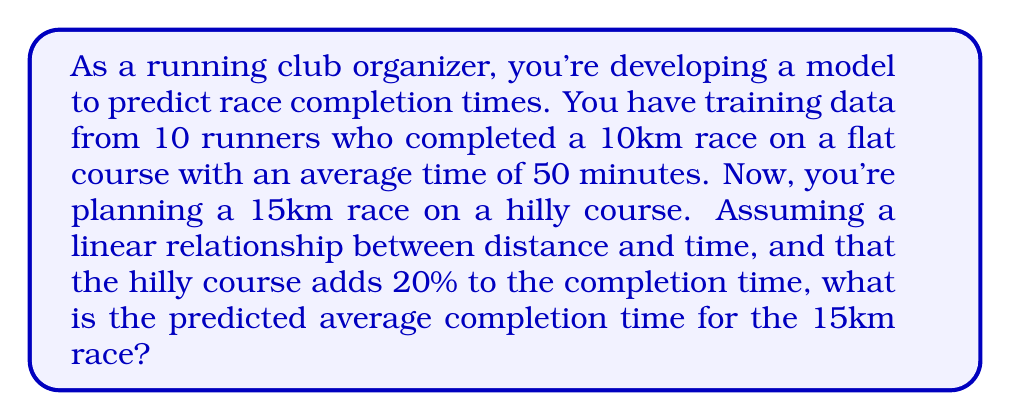Show me your answer to this math problem. Let's approach this step-by-step:

1) First, we need to establish the baseline pace for the flat 10km race:
   $$\text{Pace} = \frac{\text{Time}}{\text{Distance}} = \frac{50 \text{ minutes}}{10 \text{ km}} = 5 \text{ min/km}$$

2) Now, let's predict the time for a 15km flat course:
   $$\text{Predicted Time (flat)} = 15 \text{ km} \times 5 \text{ min/km} = 75 \text{ minutes}$$

3) The question states that the hilly course adds 20% to the completion time. To calculate this:
   $$\text{Additional Time} = 75 \text{ minutes} \times 0.20 = 15 \text{ minutes}$$

4) Therefore, the total predicted time for the 15km hilly course is:
   $$\text{Total Predicted Time} = 75 \text{ minutes} + 15 \text{ minutes} = 90 \text{ minutes}$$

This inverse problem involves using known data (10km race times) to predict unknown data (15km race times) while accounting for changes in conditions (distance and terrain).
Answer: 90 minutes 